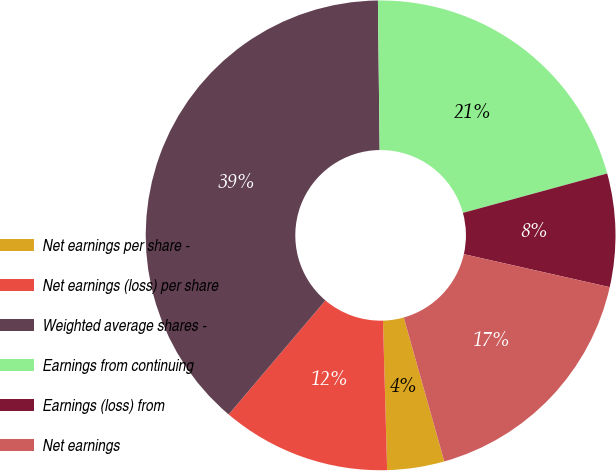Convert chart. <chart><loc_0><loc_0><loc_500><loc_500><pie_chart><fcel>Net earnings per share -<fcel>Net earnings (loss) per share<fcel>Weighted average shares -<fcel>Earnings from continuing<fcel>Earnings (loss) from<fcel>Net earnings<nl><fcel>3.93%<fcel>11.64%<fcel>38.62%<fcel>20.94%<fcel>7.78%<fcel>17.09%<nl></chart> 